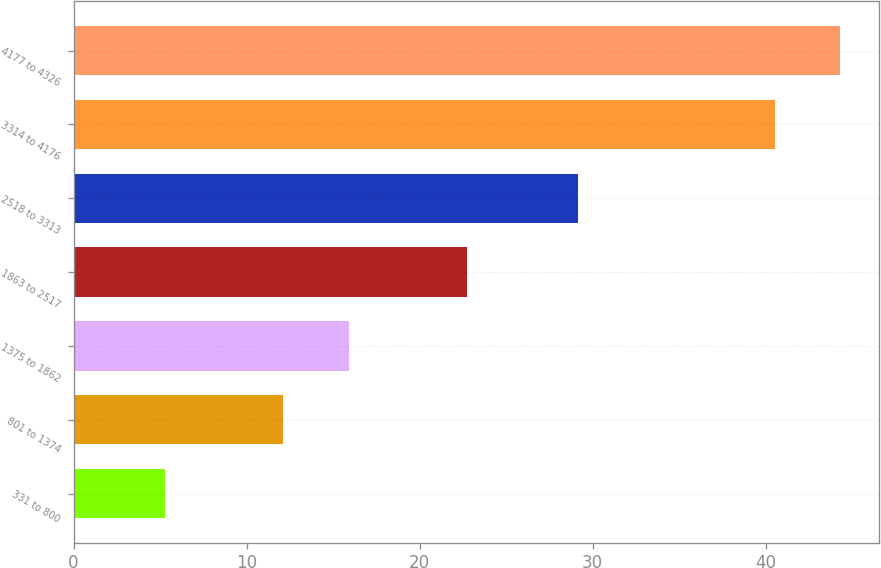Convert chart to OTSL. <chart><loc_0><loc_0><loc_500><loc_500><bar_chart><fcel>331 to 800<fcel>801 to 1374<fcel>1375 to 1862<fcel>1863 to 2517<fcel>2518 to 3313<fcel>3314 to 4176<fcel>4177 to 4326<nl><fcel>5.26<fcel>12.13<fcel>15.91<fcel>22.73<fcel>29.16<fcel>40.54<fcel>44.32<nl></chart> 